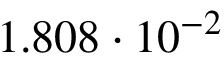Convert formula to latex. <formula><loc_0><loc_0><loc_500><loc_500>1 . 8 0 8 \cdot 1 0 ^ { - 2 }</formula> 